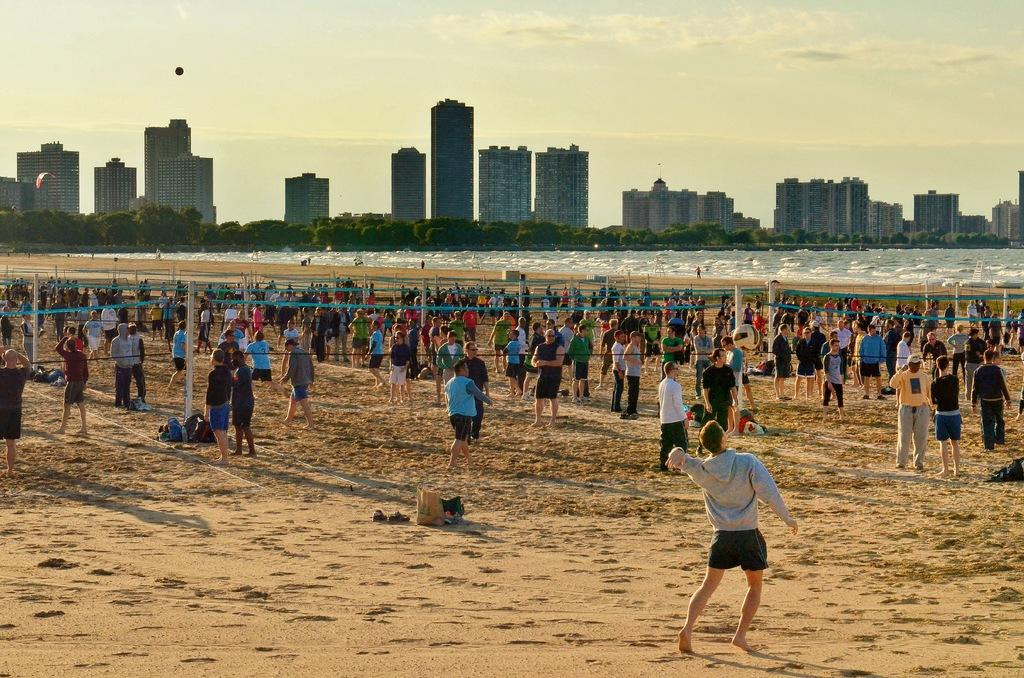Who or what is in the image? There are people in the image. What is happening with the ball in the image? A ball is in the air. What objects can be seen on the sand in the image? There are objects on the sand, which include nets and poles. What can be seen in the background of the image? Water, buildings, trees, paragliding, and the sky are visible in the background. How many fans are visible in the image? There are no fans present in the image. What type of snakes can be seen slithering on the sand in the image? There are no snakes visible in the image; it features people, a ball, and objects on the sand. 